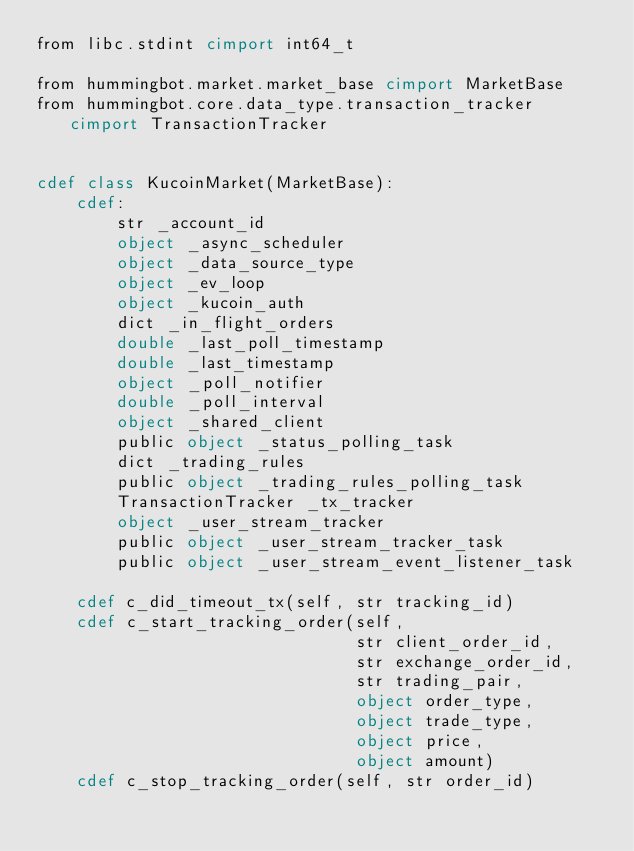Convert code to text. <code><loc_0><loc_0><loc_500><loc_500><_Cython_>from libc.stdint cimport int64_t

from hummingbot.market.market_base cimport MarketBase
from hummingbot.core.data_type.transaction_tracker cimport TransactionTracker


cdef class KucoinMarket(MarketBase):
    cdef:
        str _account_id
        object _async_scheduler
        object _data_source_type
        object _ev_loop
        object _kucoin_auth
        dict _in_flight_orders
        double _last_poll_timestamp
        double _last_timestamp
        object _poll_notifier
        double _poll_interval
        object _shared_client
        public object _status_polling_task
        dict _trading_rules
        public object _trading_rules_polling_task
        TransactionTracker _tx_tracker
        object _user_stream_tracker
        public object _user_stream_tracker_task
        public object _user_stream_event_listener_task

    cdef c_did_timeout_tx(self, str tracking_id)
    cdef c_start_tracking_order(self,
                                str client_order_id,
                                str exchange_order_id,
                                str trading_pair,
                                object order_type,
                                object trade_type,
                                object price,
                                object amount)
    cdef c_stop_tracking_order(self, str order_id)
</code> 